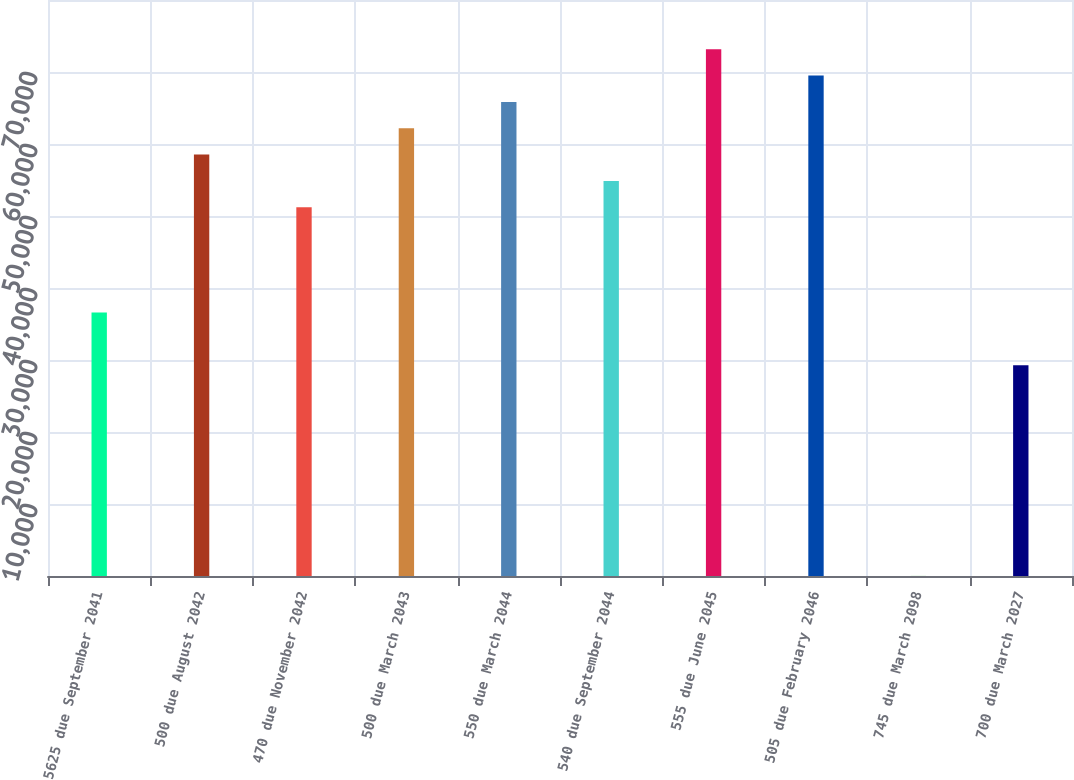Convert chart. <chart><loc_0><loc_0><loc_500><loc_500><bar_chart><fcel>5625 due September 2041<fcel>500 due August 2042<fcel>470 due November 2042<fcel>500 due March 2043<fcel>550 due March 2044<fcel>540 due September 2044<fcel>555 due June 2045<fcel>505 due February 2046<fcel>745 due March 2098<fcel>700 due March 2027<nl><fcel>36593<fcel>58533.2<fcel>51219.8<fcel>62189.9<fcel>65846.6<fcel>54876.5<fcel>73160<fcel>69503.3<fcel>26<fcel>29279.6<nl></chart> 